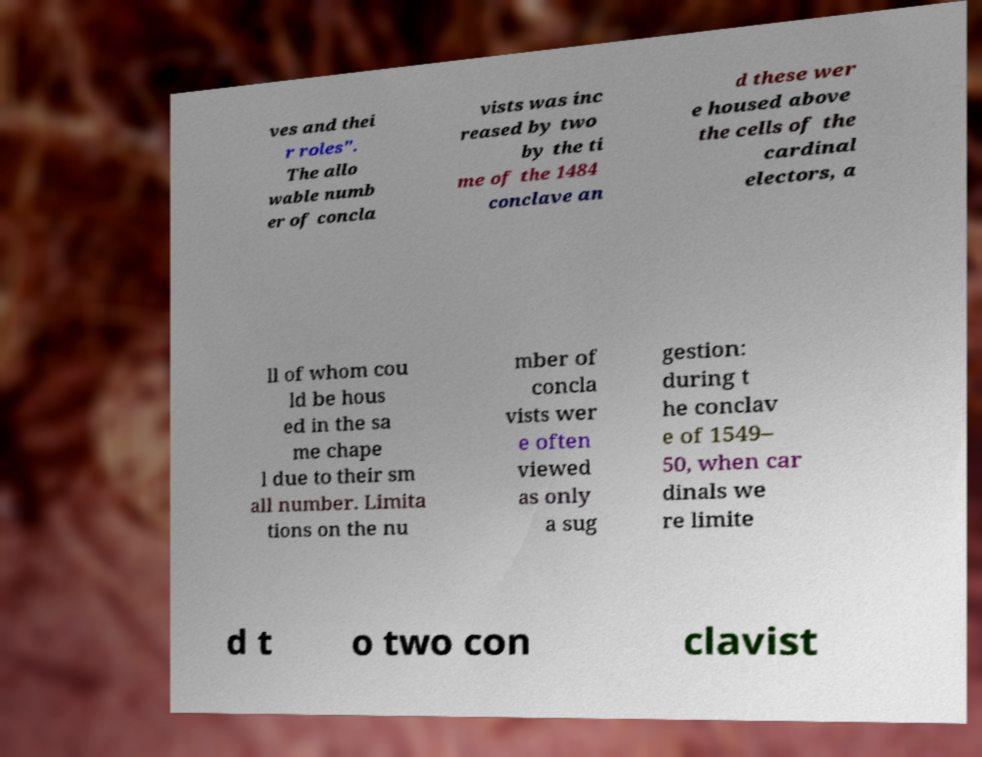Could you assist in decoding the text presented in this image and type it out clearly? ves and thei r roles". The allo wable numb er of concla vists was inc reased by two by the ti me of the 1484 conclave an d these wer e housed above the cells of the cardinal electors, a ll of whom cou ld be hous ed in the sa me chape l due to their sm all number. Limita tions on the nu mber of concla vists wer e often viewed as only a sug gestion: during t he conclav e of 1549– 50, when car dinals we re limite d t o two con clavist 